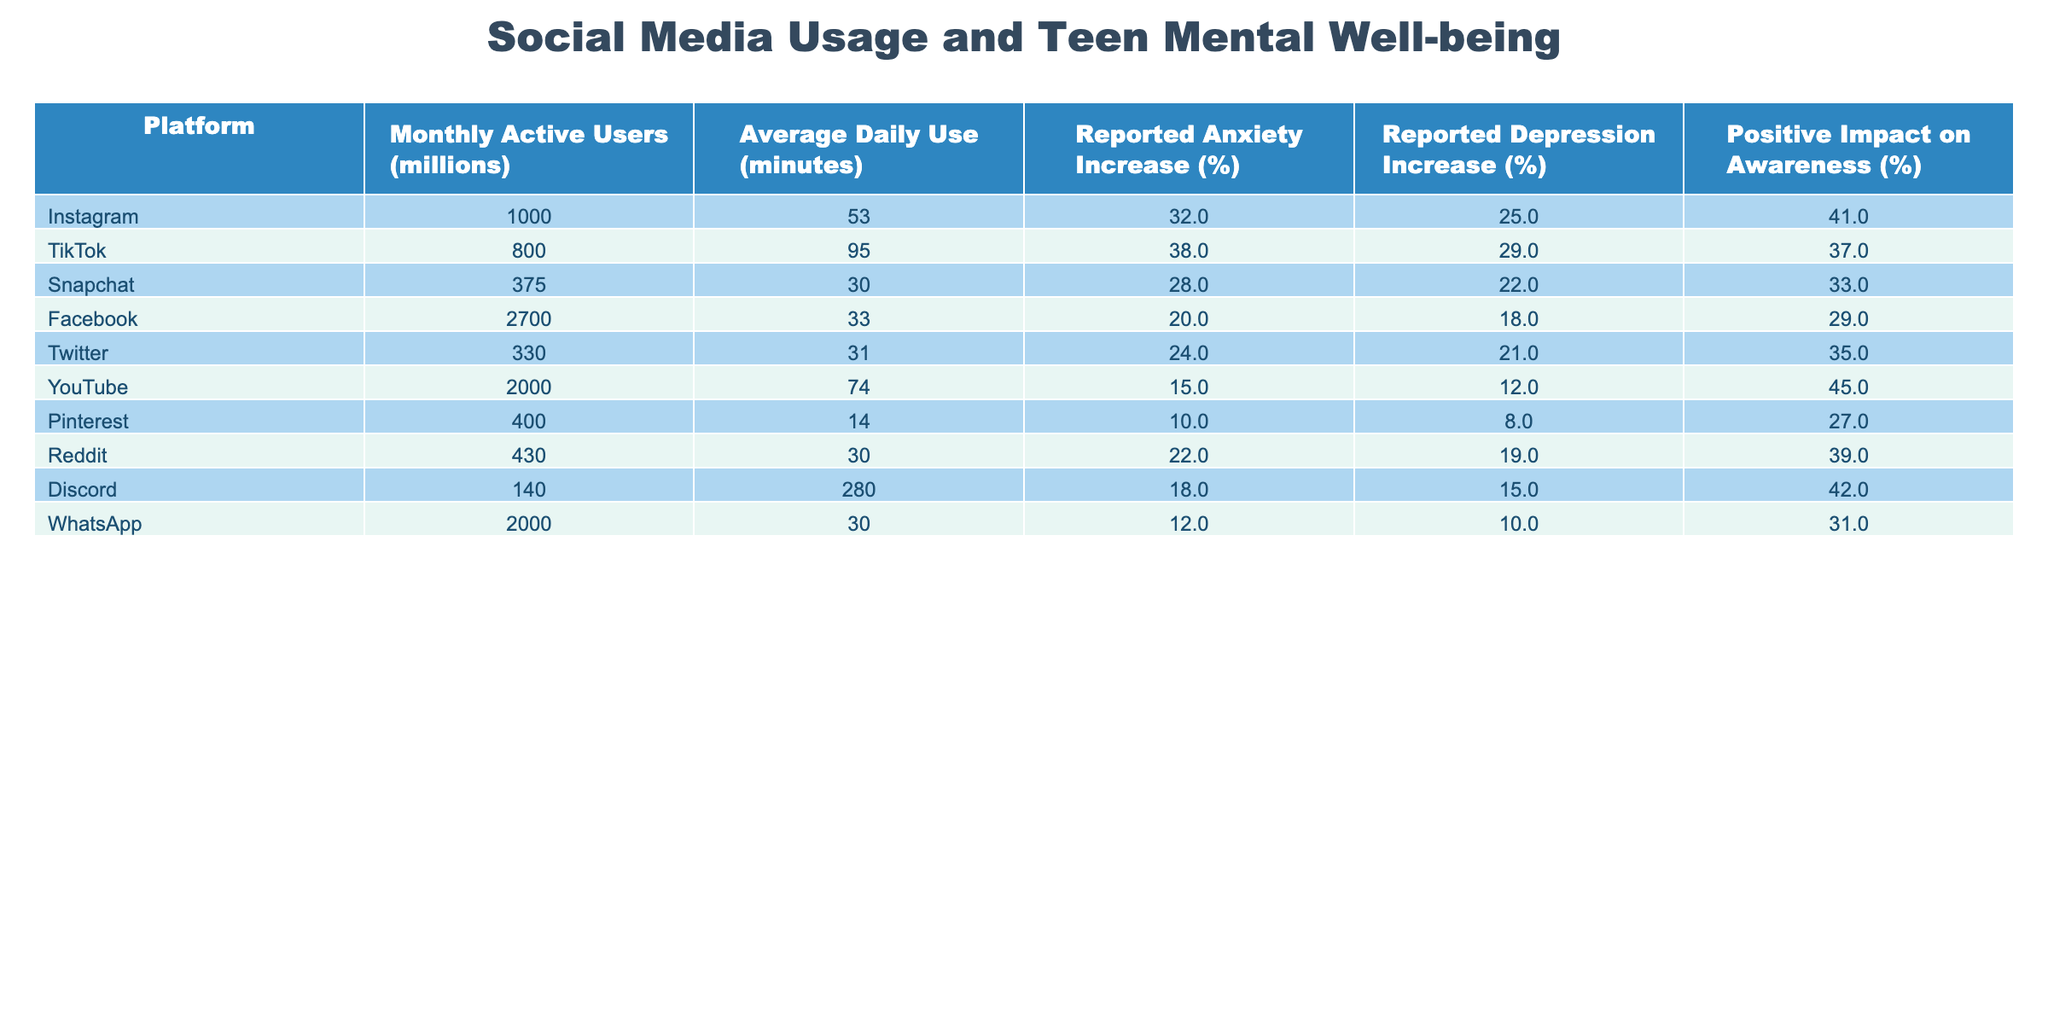What is the monthly active user count for Instagram? The table shows that Instagram has 1000 million monthly active users.
Answer: 1000 million Which platform has the highest reported anxiety increase? By examining the "Reported Anxiety Increase (%)" column, we see TikTok has the highest value at 38%.
Answer: TikTok What is the average daily use time (in minutes) for Snapchat and Discord? Looking at the "Average Daily Use (minutes)" column, Snapchat has 30 minutes and Discord has 280 minutes. The average is (30 + 280) / 2 = 155 minutes.
Answer: 155 minutes Is there a positive impact on awareness for YouTube? Yes, YouTube shows a positive impact on awareness of 45%, confirming there is an impact.
Answer: Yes Which platform shows the lowest reported depression increase? Checking the "Reported Depression Increase (%)" column, Pinterest shows the lowest at 8%.
Answer: Pinterest How much higher is the reported anxiety increase for TikTok compared to YouTube? TikTok has a reported anxiety increase of 38%, while YouTube has 15%. The difference is 38 - 15 = 23%.
Answer: 23% Which platforms have a positive impact on awareness above 40%? From the "Positive Impact on Awareness (%)" column, Instagram (41%), YouTube (45%), and Discord (42%) exceed 40%.
Answer: Instagram, YouTube, Discord What is the total reported depression increase for all platforms? Summing up the reported depression increase for all platforms gives: 25 + 29 + 22 + 18 + 21 + 12 + 8 + 19 + 15 + 10 =  289%.
Answer: 289% Which platform has the highest average daily use time? Reviewing the "Average Daily Use (minutes)" column, Discord has the highest at 280 minutes.
Answer: Discord Is it true that Facebook has a higher positive impact on awareness than Pinterest? Google the respective values, Facebook has 29% and Pinterest has 27%; hence, the statement is true.
Answer: Yes 